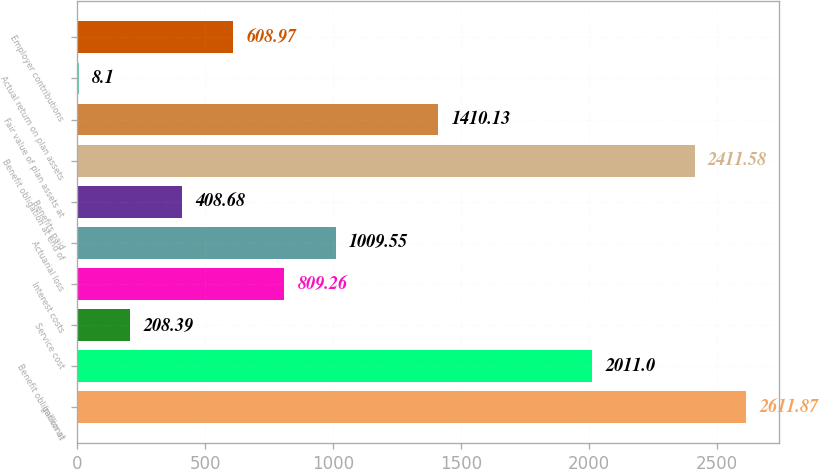Convert chart to OTSL. <chart><loc_0><loc_0><loc_500><loc_500><bar_chart><fcel>(millions)<fcel>Benefit obligation at<fcel>Service cost<fcel>Interest costs<fcel>Actuarial loss<fcel>Benefits paid<fcel>Benefit obligation at end of<fcel>Fair value of plan assets at<fcel>Actual return on plan assets<fcel>Employer contributions<nl><fcel>2611.87<fcel>2011<fcel>208.39<fcel>809.26<fcel>1009.55<fcel>408.68<fcel>2411.58<fcel>1410.13<fcel>8.1<fcel>608.97<nl></chart> 